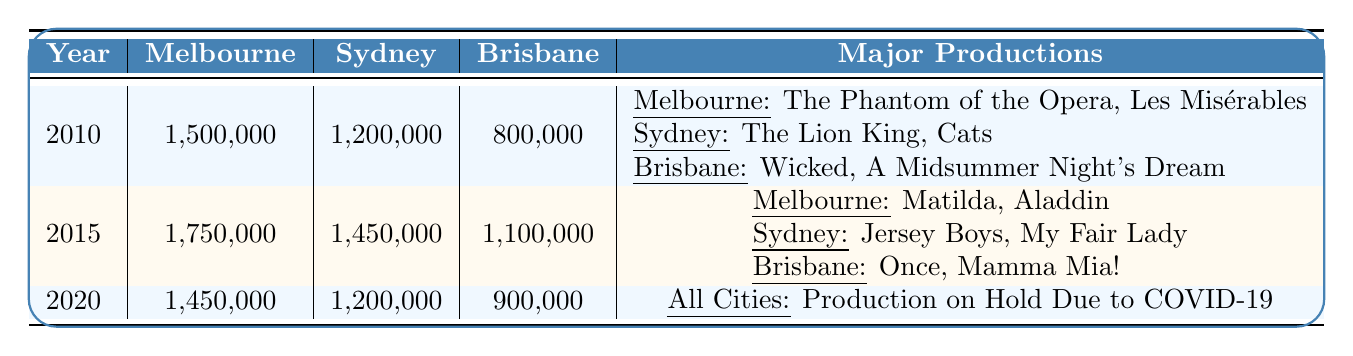What was the total attendance in Melbourne for the year 2015? The table shows that in 2015, Melbourne had an attendance of 1,750,000.
Answer: 1,750,000 Which city had the highest attendance in 2018? In 2018, the table indicates that Melbourne had 1,900,000 attendees, Sydney had 1,600,000 attendees, and Brisbane had 1,250,000 attendees. Therefore, Melbourne had the highest attendance.
Answer: Melbourne What is the difference in attendance between Sydney in 2019 and Brisbane in 2020? In 2019, Sydney had an attendance of 1,650,000 and in 2020, Brisbane had 900,000. The difference is calculated as 1,650,000 - 900,000 = 750,000.
Answer: 750,000 Did any city have productions on hold due to COVID-19 in 2020? According to the table, all cities had productions on hold due to COVID-19 in 2020.
Answer: Yes What was the increase in Melbourne's attendance from 2010 to 2019? The attendance in Melbourne was 1,500,000 in 2010 and 1,950,000 in 2019. The increase is calculated as 1,950,000 - 1,500,000 = 450,000.
Answer: 450,000 Which major production was present in both Melbourne in 2016 and Sydney in 2017? The table shows that Melbourne had "Harry Potter and the Cursed Child" and "The Book of Mormon" in 2016, and Sydney had "Les Misérables" and "Beautiful" in 2017. There are no common productions present in both cities for those years.
Answer: None What was the average attendance for Brisbane from 2010 to 2015? The attendances for Brisbane from 2010 to 2015 are: 800,000 (2010), 850,000 (2011), 900,000 (2012), 950,000 (2013), 1,000,000 (2014), and 1,100,000 (2015). The total attendance is 800,000 + 850,000 + 900,000 + 950,000 + 1,000,000 + 1,100,000 = 5,600,000. Dividing by 6 gives an average of 5,600,000 / 6 = 933,333.33, rounded down to 933,333.
Answer: 933,333 What was the trend of theatre attendance in Melbourne from 2010 to 2019? By examining the table, it's clear that Melbourne's attendance increased each year from 1,500,000 in 2010 to 1,950,000 in 2019, indicating a consistent upward trend in attendance over the years.
Answer: Increasing If Brisbane's attendance in 2013 was 950,000, how much more did it grow by 2018? Brisbane's attendance in 2013 was 950,000 and in 2018 it was 1,250,000. The growth is calculated as 1,250,000 - 950,000 = 300,000.
Answer: 300,000 Which year saw the highest total attendance in Sydney from 2010 to 2019? Looking at the table, the highest attendance in Sydney was in 2019, with a total of 1,650,000 attendees.
Answer: 2019 